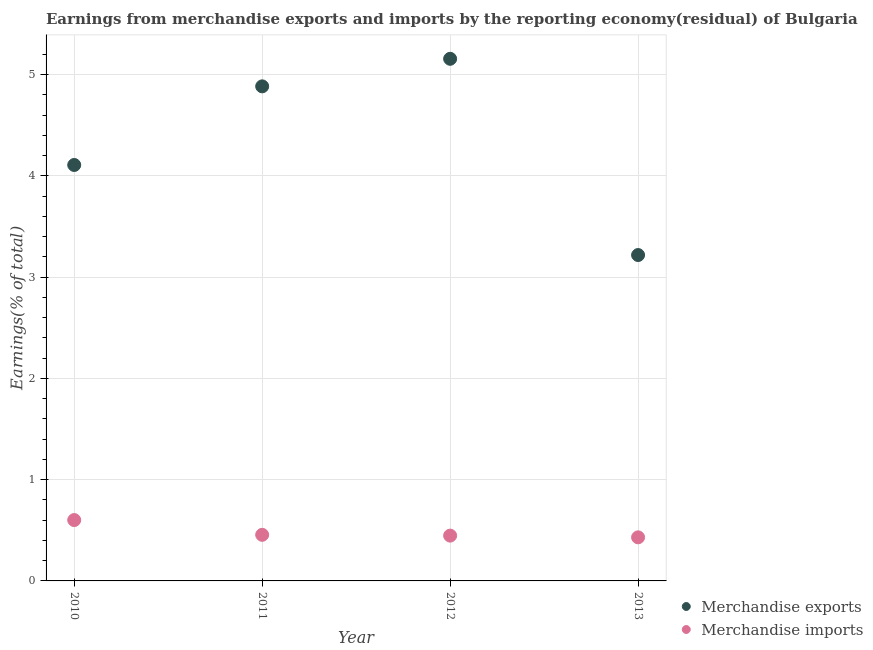What is the earnings from merchandise imports in 2012?
Ensure brevity in your answer.  0.45. Across all years, what is the maximum earnings from merchandise imports?
Make the answer very short. 0.6. Across all years, what is the minimum earnings from merchandise exports?
Offer a very short reply. 3.22. In which year was the earnings from merchandise imports maximum?
Give a very brief answer. 2010. In which year was the earnings from merchandise exports minimum?
Provide a succinct answer. 2013. What is the total earnings from merchandise imports in the graph?
Your answer should be very brief. 1.93. What is the difference between the earnings from merchandise imports in 2010 and that in 2013?
Your answer should be compact. 0.17. What is the difference between the earnings from merchandise imports in 2011 and the earnings from merchandise exports in 2010?
Give a very brief answer. -3.65. What is the average earnings from merchandise imports per year?
Give a very brief answer. 0.48. In the year 2012, what is the difference between the earnings from merchandise imports and earnings from merchandise exports?
Offer a very short reply. -4.71. What is the ratio of the earnings from merchandise imports in 2010 to that in 2013?
Your answer should be compact. 1.4. What is the difference between the highest and the second highest earnings from merchandise imports?
Your answer should be very brief. 0.15. What is the difference between the highest and the lowest earnings from merchandise imports?
Offer a terse response. 0.17. Does the earnings from merchandise imports monotonically increase over the years?
Provide a short and direct response. No. Is the earnings from merchandise exports strictly less than the earnings from merchandise imports over the years?
Your answer should be compact. No. Does the graph contain grids?
Offer a terse response. Yes. What is the title of the graph?
Keep it short and to the point. Earnings from merchandise exports and imports by the reporting economy(residual) of Bulgaria. Does "Investment in Transport" appear as one of the legend labels in the graph?
Make the answer very short. No. What is the label or title of the Y-axis?
Your answer should be very brief. Earnings(% of total). What is the Earnings(% of total) in Merchandise exports in 2010?
Offer a very short reply. 4.11. What is the Earnings(% of total) of Merchandise imports in 2010?
Your response must be concise. 0.6. What is the Earnings(% of total) in Merchandise exports in 2011?
Provide a succinct answer. 4.88. What is the Earnings(% of total) of Merchandise imports in 2011?
Give a very brief answer. 0.46. What is the Earnings(% of total) of Merchandise exports in 2012?
Your answer should be very brief. 5.16. What is the Earnings(% of total) in Merchandise imports in 2012?
Offer a very short reply. 0.45. What is the Earnings(% of total) in Merchandise exports in 2013?
Offer a terse response. 3.22. What is the Earnings(% of total) in Merchandise imports in 2013?
Your answer should be very brief. 0.43. Across all years, what is the maximum Earnings(% of total) of Merchandise exports?
Your response must be concise. 5.16. Across all years, what is the maximum Earnings(% of total) of Merchandise imports?
Your answer should be compact. 0.6. Across all years, what is the minimum Earnings(% of total) of Merchandise exports?
Make the answer very short. 3.22. Across all years, what is the minimum Earnings(% of total) of Merchandise imports?
Keep it short and to the point. 0.43. What is the total Earnings(% of total) in Merchandise exports in the graph?
Keep it short and to the point. 17.37. What is the total Earnings(% of total) in Merchandise imports in the graph?
Provide a succinct answer. 1.93. What is the difference between the Earnings(% of total) of Merchandise exports in 2010 and that in 2011?
Provide a succinct answer. -0.78. What is the difference between the Earnings(% of total) of Merchandise imports in 2010 and that in 2011?
Ensure brevity in your answer.  0.15. What is the difference between the Earnings(% of total) of Merchandise exports in 2010 and that in 2012?
Offer a very short reply. -1.05. What is the difference between the Earnings(% of total) of Merchandise imports in 2010 and that in 2012?
Keep it short and to the point. 0.15. What is the difference between the Earnings(% of total) in Merchandise exports in 2010 and that in 2013?
Your answer should be compact. 0.89. What is the difference between the Earnings(% of total) in Merchandise imports in 2010 and that in 2013?
Your answer should be compact. 0.17. What is the difference between the Earnings(% of total) in Merchandise exports in 2011 and that in 2012?
Give a very brief answer. -0.27. What is the difference between the Earnings(% of total) of Merchandise imports in 2011 and that in 2012?
Your answer should be compact. 0.01. What is the difference between the Earnings(% of total) in Merchandise exports in 2011 and that in 2013?
Your answer should be compact. 1.67. What is the difference between the Earnings(% of total) of Merchandise imports in 2011 and that in 2013?
Your response must be concise. 0.02. What is the difference between the Earnings(% of total) in Merchandise exports in 2012 and that in 2013?
Make the answer very short. 1.94. What is the difference between the Earnings(% of total) of Merchandise imports in 2012 and that in 2013?
Your answer should be very brief. 0.02. What is the difference between the Earnings(% of total) in Merchandise exports in 2010 and the Earnings(% of total) in Merchandise imports in 2011?
Provide a short and direct response. 3.65. What is the difference between the Earnings(% of total) of Merchandise exports in 2010 and the Earnings(% of total) of Merchandise imports in 2012?
Keep it short and to the point. 3.66. What is the difference between the Earnings(% of total) of Merchandise exports in 2010 and the Earnings(% of total) of Merchandise imports in 2013?
Your answer should be very brief. 3.68. What is the difference between the Earnings(% of total) of Merchandise exports in 2011 and the Earnings(% of total) of Merchandise imports in 2012?
Your response must be concise. 4.44. What is the difference between the Earnings(% of total) of Merchandise exports in 2011 and the Earnings(% of total) of Merchandise imports in 2013?
Offer a terse response. 4.45. What is the difference between the Earnings(% of total) in Merchandise exports in 2012 and the Earnings(% of total) in Merchandise imports in 2013?
Ensure brevity in your answer.  4.73. What is the average Earnings(% of total) of Merchandise exports per year?
Give a very brief answer. 4.34. What is the average Earnings(% of total) of Merchandise imports per year?
Offer a very short reply. 0.48. In the year 2010, what is the difference between the Earnings(% of total) of Merchandise exports and Earnings(% of total) of Merchandise imports?
Offer a very short reply. 3.51. In the year 2011, what is the difference between the Earnings(% of total) in Merchandise exports and Earnings(% of total) in Merchandise imports?
Your response must be concise. 4.43. In the year 2012, what is the difference between the Earnings(% of total) in Merchandise exports and Earnings(% of total) in Merchandise imports?
Your answer should be compact. 4.71. In the year 2013, what is the difference between the Earnings(% of total) in Merchandise exports and Earnings(% of total) in Merchandise imports?
Offer a terse response. 2.79. What is the ratio of the Earnings(% of total) of Merchandise exports in 2010 to that in 2011?
Your answer should be compact. 0.84. What is the ratio of the Earnings(% of total) in Merchandise imports in 2010 to that in 2011?
Provide a succinct answer. 1.32. What is the ratio of the Earnings(% of total) of Merchandise exports in 2010 to that in 2012?
Offer a terse response. 0.8. What is the ratio of the Earnings(% of total) of Merchandise imports in 2010 to that in 2012?
Offer a terse response. 1.34. What is the ratio of the Earnings(% of total) in Merchandise exports in 2010 to that in 2013?
Your answer should be very brief. 1.28. What is the ratio of the Earnings(% of total) in Merchandise imports in 2010 to that in 2013?
Your answer should be compact. 1.4. What is the ratio of the Earnings(% of total) in Merchandise exports in 2011 to that in 2012?
Keep it short and to the point. 0.95. What is the ratio of the Earnings(% of total) in Merchandise imports in 2011 to that in 2012?
Offer a very short reply. 1.02. What is the ratio of the Earnings(% of total) of Merchandise exports in 2011 to that in 2013?
Make the answer very short. 1.52. What is the ratio of the Earnings(% of total) of Merchandise imports in 2011 to that in 2013?
Your answer should be compact. 1.06. What is the ratio of the Earnings(% of total) of Merchandise exports in 2012 to that in 2013?
Your response must be concise. 1.6. What is the ratio of the Earnings(% of total) in Merchandise imports in 2012 to that in 2013?
Your response must be concise. 1.04. What is the difference between the highest and the second highest Earnings(% of total) in Merchandise exports?
Make the answer very short. 0.27. What is the difference between the highest and the second highest Earnings(% of total) in Merchandise imports?
Your response must be concise. 0.15. What is the difference between the highest and the lowest Earnings(% of total) of Merchandise exports?
Give a very brief answer. 1.94. What is the difference between the highest and the lowest Earnings(% of total) of Merchandise imports?
Your answer should be compact. 0.17. 